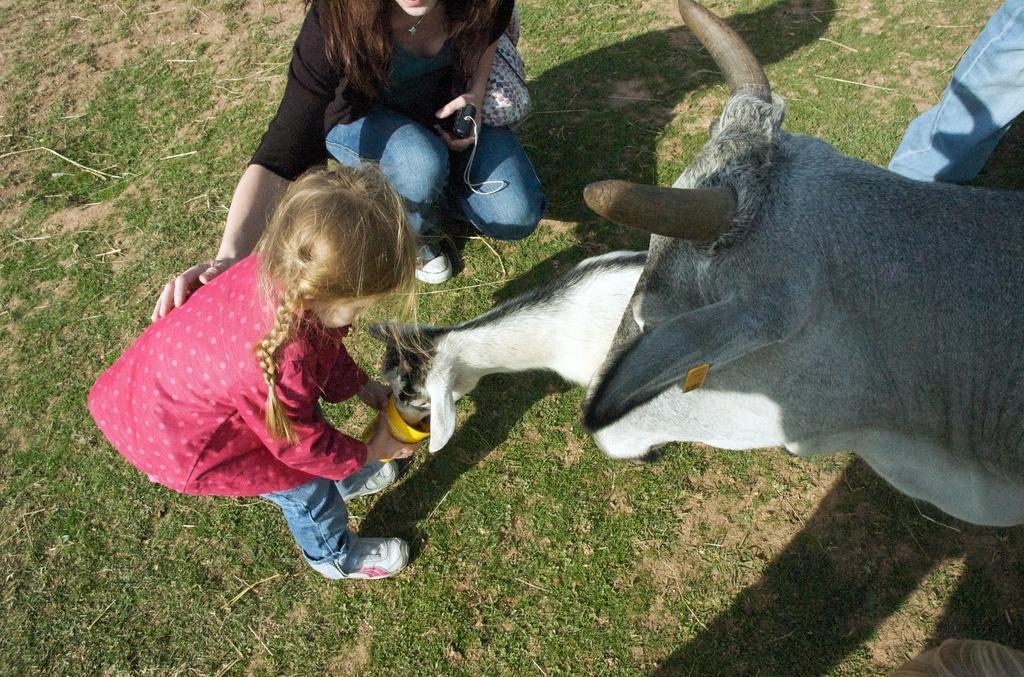In one or two sentences, can you explain what this image depicts? This image is taken outdoors. At the bottom of the image there is a ground with grass on it. On the right side of the image a person is standing and there is a cow and a calf on the ground. A calf is drinking water in a tumbler. In the middle of the image a woman is in a squatting position and a girl is holding a tumbler in her hands. 